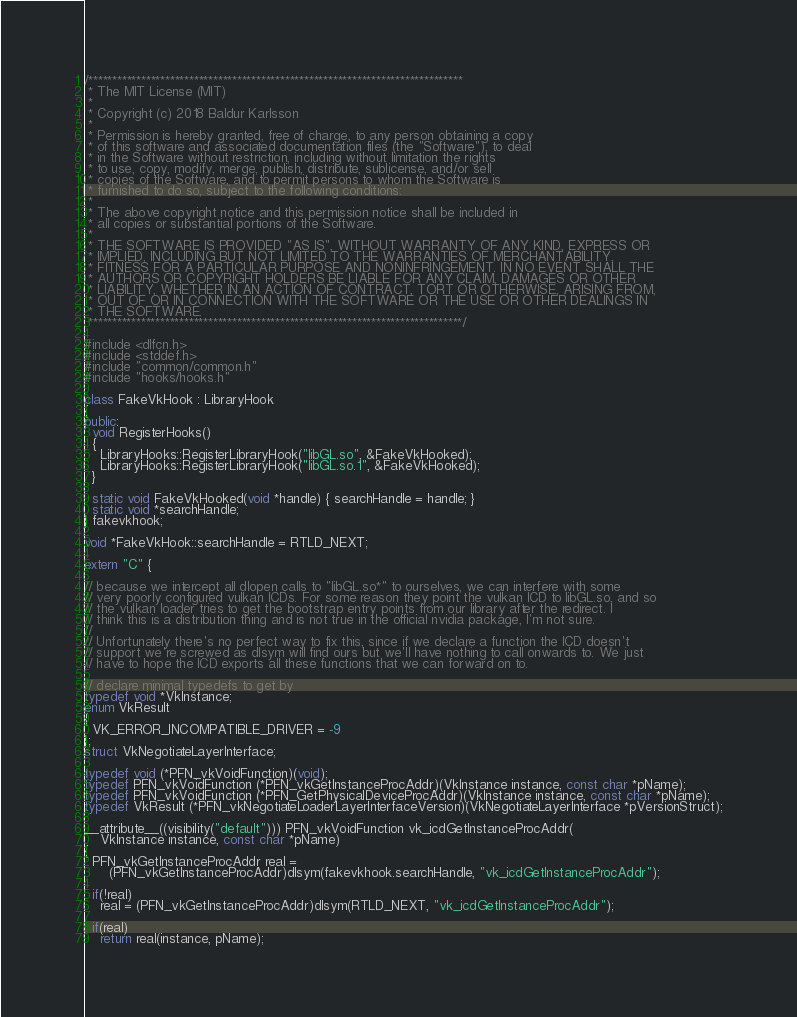<code> <loc_0><loc_0><loc_500><loc_500><_C++_>/******************************************************************************
 * The MIT License (MIT)
 *
 * Copyright (c) 2018 Baldur Karlsson
 *
 * Permission is hereby granted, free of charge, to any person obtaining a copy
 * of this software and associated documentation files (the "Software"), to deal
 * in the Software without restriction, including without limitation the rights
 * to use, copy, modify, merge, publish, distribute, sublicense, and/or sell
 * copies of the Software, and to permit persons to whom the Software is
 * furnished to do so, subject to the following conditions:
 *
 * The above copyright notice and this permission notice shall be included in
 * all copies or substantial portions of the Software.
 *
 * THE SOFTWARE IS PROVIDED "AS IS", WITHOUT WARRANTY OF ANY KIND, EXPRESS OR
 * IMPLIED, INCLUDING BUT NOT LIMITED TO THE WARRANTIES OF MERCHANTABILITY,
 * FITNESS FOR A PARTICULAR PURPOSE AND NONINFRINGEMENT. IN NO EVENT SHALL THE
 * AUTHORS OR COPYRIGHT HOLDERS BE LIABLE FOR ANY CLAIM, DAMAGES OR OTHER
 * LIABILITY, WHETHER IN AN ACTION OF CONTRACT, TORT OR OTHERWISE, ARISING FROM,
 * OUT OF OR IN CONNECTION WITH THE SOFTWARE OR THE USE OR OTHER DEALINGS IN
 * THE SOFTWARE.
 ******************************************************************************/

#include <dlfcn.h>
#include <stddef.h>
#include "common/common.h"
#include "hooks/hooks.h"

class FakeVkHook : LibraryHook
{
public:
  void RegisterHooks()
  {
    LibraryHooks::RegisterLibraryHook("libGL.so", &FakeVkHooked);
    LibraryHooks::RegisterLibraryHook("libGL.so.1", &FakeVkHooked);
  }

  static void FakeVkHooked(void *handle) { searchHandle = handle; }
  static void *searchHandle;
} fakevkhook;

void *FakeVkHook::searchHandle = RTLD_NEXT;

extern "C" {

// because we intercept all dlopen calls to "libGL.so*" to ourselves, we can interfere with some
// very poorly configured vulkan ICDs. For some reason they point the vulkan ICD to libGL.so, and so
// the vulkan loader tries to get the bootstrap entry points from our library after the redirect. I
// think this is a distribution thing and is not true in the official nvidia package, I'm not sure.
//
// Unfortunately there's no perfect way to fix this, since if we declare a function the ICD doesn't
// support we're screwed as dlsym will find ours but we'll have nothing to call onwards to. We just
// have to hope the ICD exports all these functions that we can forward on to.

// declare minimal typedefs to get by
typedef void *VkInstance;
enum VkResult
{
  VK_ERROR_INCOMPATIBLE_DRIVER = -9
};
struct VkNegotiateLayerInterface;

typedef void (*PFN_vkVoidFunction)(void);
typedef PFN_vkVoidFunction (*PFN_vkGetInstanceProcAddr)(VkInstance instance, const char *pName);
typedef PFN_vkVoidFunction (*PFN_GetPhysicalDeviceProcAddr)(VkInstance instance, const char *pName);
typedef VkResult (*PFN_vkNegotiateLoaderLayerInterfaceVersion)(VkNegotiateLayerInterface *pVersionStruct);

__attribute__((visibility("default"))) PFN_vkVoidFunction vk_icdGetInstanceProcAddr(
    VkInstance instance, const char *pName)
{
  PFN_vkGetInstanceProcAddr real =
      (PFN_vkGetInstanceProcAddr)dlsym(fakevkhook.searchHandle, "vk_icdGetInstanceProcAddr");

  if(!real)
    real = (PFN_vkGetInstanceProcAddr)dlsym(RTLD_NEXT, "vk_icdGetInstanceProcAddr");

  if(real)
    return real(instance, pName);
</code> 